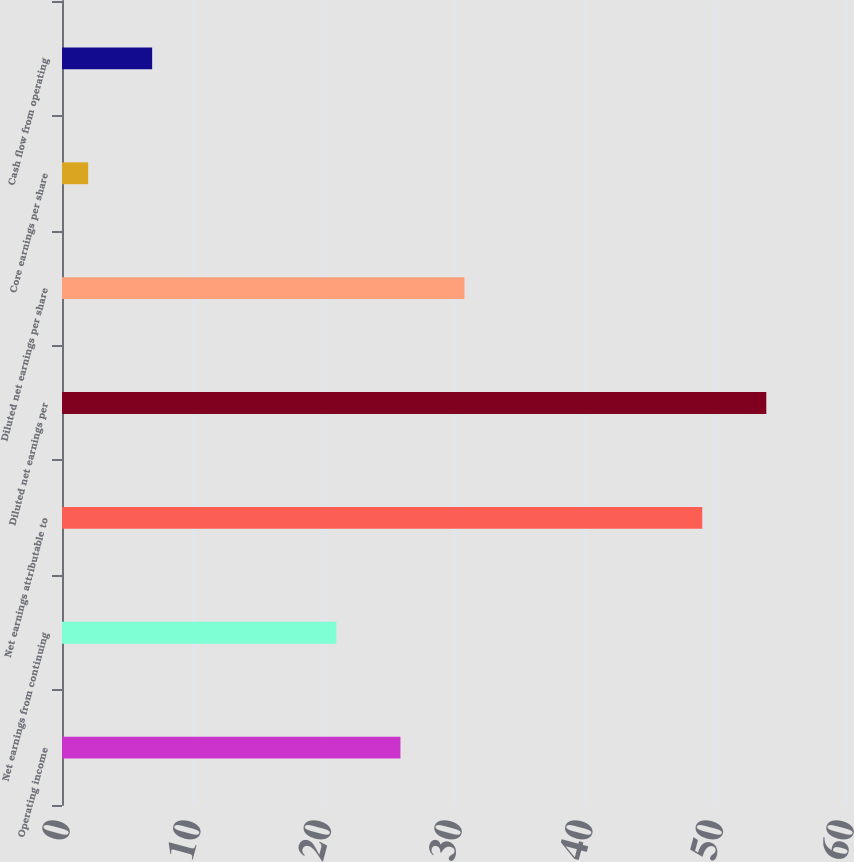Convert chart. <chart><loc_0><loc_0><loc_500><loc_500><bar_chart><fcel>Operating income<fcel>Net earnings from continuing<fcel>Net earnings attributable to<fcel>Diluted net earnings per<fcel>Diluted net earnings per share<fcel>Core earnings per share<fcel>Cash flow from operating<nl><fcel>25.9<fcel>21<fcel>49<fcel>53.9<fcel>30.8<fcel>2<fcel>6.9<nl></chart> 